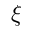Convert formula to latex. <formula><loc_0><loc_0><loc_500><loc_500>\xi</formula> 